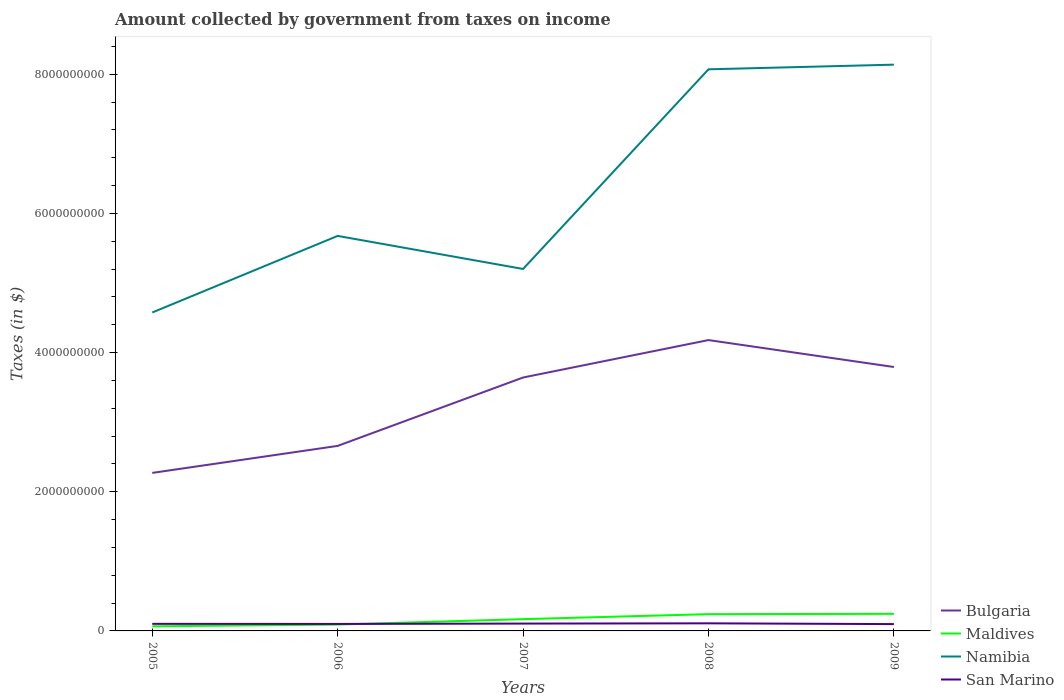Does the line corresponding to Namibia intersect with the line corresponding to San Marino?
Give a very brief answer. No. Is the number of lines equal to the number of legend labels?
Your answer should be compact. Yes. Across all years, what is the maximum amount collected by government from taxes on income in San Marino?
Your answer should be compact. 9.80e+07. In which year was the amount collected by government from taxes on income in Namibia maximum?
Offer a very short reply. 2005. What is the total amount collected by government from taxes on income in San Marino in the graph?
Provide a short and direct response. 7.55e+06. What is the difference between the highest and the second highest amount collected by government from taxes on income in Bulgaria?
Keep it short and to the point. 1.91e+09. Is the amount collected by government from taxes on income in Namibia strictly greater than the amount collected by government from taxes on income in San Marino over the years?
Your response must be concise. No. What is the difference between two consecutive major ticks on the Y-axis?
Ensure brevity in your answer.  2.00e+09. Are the values on the major ticks of Y-axis written in scientific E-notation?
Offer a very short reply. No. Does the graph contain any zero values?
Make the answer very short. No. Does the graph contain grids?
Provide a short and direct response. No. How many legend labels are there?
Give a very brief answer. 4. How are the legend labels stacked?
Your answer should be very brief. Vertical. What is the title of the graph?
Ensure brevity in your answer.  Amount collected by government from taxes on income. Does "Cyprus" appear as one of the legend labels in the graph?
Provide a succinct answer. No. What is the label or title of the Y-axis?
Ensure brevity in your answer.  Taxes (in $). What is the Taxes (in $) in Bulgaria in 2005?
Keep it short and to the point. 2.27e+09. What is the Taxes (in $) in Maldives in 2005?
Offer a terse response. 6.57e+07. What is the Taxes (in $) in Namibia in 2005?
Keep it short and to the point. 4.58e+09. What is the Taxes (in $) in San Marino in 2005?
Keep it short and to the point. 1.02e+08. What is the Taxes (in $) in Bulgaria in 2006?
Keep it short and to the point. 2.66e+09. What is the Taxes (in $) of Maldives in 2006?
Ensure brevity in your answer.  9.14e+07. What is the Taxes (in $) in Namibia in 2006?
Ensure brevity in your answer.  5.68e+09. What is the Taxes (in $) of San Marino in 2006?
Offer a terse response. 1.00e+08. What is the Taxes (in $) of Bulgaria in 2007?
Your answer should be very brief. 3.64e+09. What is the Taxes (in $) in Maldives in 2007?
Keep it short and to the point. 1.69e+08. What is the Taxes (in $) in Namibia in 2007?
Ensure brevity in your answer.  5.20e+09. What is the Taxes (in $) of San Marino in 2007?
Offer a very short reply. 1.06e+08. What is the Taxes (in $) in Bulgaria in 2008?
Offer a very short reply. 4.18e+09. What is the Taxes (in $) of Maldives in 2008?
Provide a short and direct response. 2.41e+08. What is the Taxes (in $) in Namibia in 2008?
Your answer should be compact. 8.07e+09. What is the Taxes (in $) in San Marino in 2008?
Make the answer very short. 1.09e+08. What is the Taxes (in $) in Bulgaria in 2009?
Keep it short and to the point. 3.79e+09. What is the Taxes (in $) of Maldives in 2009?
Your answer should be compact. 2.46e+08. What is the Taxes (in $) of Namibia in 2009?
Make the answer very short. 8.14e+09. What is the Taxes (in $) in San Marino in 2009?
Make the answer very short. 9.80e+07. Across all years, what is the maximum Taxes (in $) in Bulgaria?
Your answer should be very brief. 4.18e+09. Across all years, what is the maximum Taxes (in $) of Maldives?
Keep it short and to the point. 2.46e+08. Across all years, what is the maximum Taxes (in $) in Namibia?
Give a very brief answer. 8.14e+09. Across all years, what is the maximum Taxes (in $) of San Marino?
Offer a terse response. 1.09e+08. Across all years, what is the minimum Taxes (in $) of Bulgaria?
Provide a short and direct response. 2.27e+09. Across all years, what is the minimum Taxes (in $) in Maldives?
Keep it short and to the point. 6.57e+07. Across all years, what is the minimum Taxes (in $) of Namibia?
Make the answer very short. 4.58e+09. Across all years, what is the minimum Taxes (in $) in San Marino?
Your answer should be very brief. 9.80e+07. What is the total Taxes (in $) in Bulgaria in the graph?
Your response must be concise. 1.65e+1. What is the total Taxes (in $) in Maldives in the graph?
Keep it short and to the point. 8.13e+08. What is the total Taxes (in $) in Namibia in the graph?
Provide a short and direct response. 3.17e+1. What is the total Taxes (in $) in San Marino in the graph?
Provide a succinct answer. 5.15e+08. What is the difference between the Taxes (in $) of Bulgaria in 2005 and that in 2006?
Provide a succinct answer. -3.88e+08. What is the difference between the Taxes (in $) of Maldives in 2005 and that in 2006?
Make the answer very short. -2.57e+07. What is the difference between the Taxes (in $) of Namibia in 2005 and that in 2006?
Your response must be concise. -1.10e+09. What is the difference between the Taxes (in $) of San Marino in 2005 and that in 2006?
Offer a terse response. 1.49e+06. What is the difference between the Taxes (in $) of Bulgaria in 2005 and that in 2007?
Your answer should be compact. -1.37e+09. What is the difference between the Taxes (in $) in Maldives in 2005 and that in 2007?
Offer a terse response. -1.03e+08. What is the difference between the Taxes (in $) of Namibia in 2005 and that in 2007?
Your answer should be very brief. -6.25e+08. What is the difference between the Taxes (in $) of San Marino in 2005 and that in 2007?
Provide a short and direct response. -3.79e+06. What is the difference between the Taxes (in $) of Bulgaria in 2005 and that in 2008?
Provide a short and direct response. -1.91e+09. What is the difference between the Taxes (in $) of Maldives in 2005 and that in 2008?
Make the answer very short. -1.75e+08. What is the difference between the Taxes (in $) in Namibia in 2005 and that in 2008?
Your answer should be compact. -3.49e+09. What is the difference between the Taxes (in $) in San Marino in 2005 and that in 2008?
Offer a very short reply. -7.45e+06. What is the difference between the Taxes (in $) in Bulgaria in 2005 and that in 2009?
Offer a very short reply. -1.52e+09. What is the difference between the Taxes (in $) of Maldives in 2005 and that in 2009?
Your answer should be compact. -1.80e+08. What is the difference between the Taxes (in $) of Namibia in 2005 and that in 2009?
Make the answer very short. -3.56e+09. What is the difference between the Taxes (in $) of San Marino in 2005 and that in 2009?
Keep it short and to the point. 3.76e+06. What is the difference between the Taxes (in $) of Bulgaria in 2006 and that in 2007?
Your response must be concise. -9.83e+08. What is the difference between the Taxes (in $) of Maldives in 2006 and that in 2007?
Keep it short and to the point. -7.76e+07. What is the difference between the Taxes (in $) in Namibia in 2006 and that in 2007?
Your response must be concise. 4.75e+08. What is the difference between the Taxes (in $) of San Marino in 2006 and that in 2007?
Provide a succinct answer. -5.29e+06. What is the difference between the Taxes (in $) of Bulgaria in 2006 and that in 2008?
Ensure brevity in your answer.  -1.52e+09. What is the difference between the Taxes (in $) in Maldives in 2006 and that in 2008?
Keep it short and to the point. -1.49e+08. What is the difference between the Taxes (in $) of Namibia in 2006 and that in 2008?
Provide a short and direct response. -2.39e+09. What is the difference between the Taxes (in $) in San Marino in 2006 and that in 2008?
Make the answer very short. -8.94e+06. What is the difference between the Taxes (in $) in Bulgaria in 2006 and that in 2009?
Keep it short and to the point. -1.13e+09. What is the difference between the Taxes (in $) of Maldives in 2006 and that in 2009?
Your answer should be very brief. -1.54e+08. What is the difference between the Taxes (in $) of Namibia in 2006 and that in 2009?
Make the answer very short. -2.46e+09. What is the difference between the Taxes (in $) in San Marino in 2006 and that in 2009?
Offer a terse response. 2.27e+06. What is the difference between the Taxes (in $) in Bulgaria in 2007 and that in 2008?
Ensure brevity in your answer.  -5.38e+08. What is the difference between the Taxes (in $) of Maldives in 2007 and that in 2008?
Provide a succinct answer. -7.18e+07. What is the difference between the Taxes (in $) in Namibia in 2007 and that in 2008?
Your response must be concise. -2.87e+09. What is the difference between the Taxes (in $) of San Marino in 2007 and that in 2008?
Your answer should be very brief. -3.65e+06. What is the difference between the Taxes (in $) in Bulgaria in 2007 and that in 2009?
Make the answer very short. -1.51e+08. What is the difference between the Taxes (in $) of Maldives in 2007 and that in 2009?
Ensure brevity in your answer.  -7.67e+07. What is the difference between the Taxes (in $) in Namibia in 2007 and that in 2009?
Give a very brief answer. -2.94e+09. What is the difference between the Taxes (in $) of San Marino in 2007 and that in 2009?
Ensure brevity in your answer.  7.55e+06. What is the difference between the Taxes (in $) in Bulgaria in 2008 and that in 2009?
Your answer should be compact. 3.87e+08. What is the difference between the Taxes (in $) in Maldives in 2008 and that in 2009?
Your answer should be compact. -4.90e+06. What is the difference between the Taxes (in $) of Namibia in 2008 and that in 2009?
Offer a terse response. -6.70e+07. What is the difference between the Taxes (in $) of San Marino in 2008 and that in 2009?
Provide a succinct answer. 1.12e+07. What is the difference between the Taxes (in $) of Bulgaria in 2005 and the Taxes (in $) of Maldives in 2006?
Ensure brevity in your answer.  2.18e+09. What is the difference between the Taxes (in $) of Bulgaria in 2005 and the Taxes (in $) of Namibia in 2006?
Make the answer very short. -3.41e+09. What is the difference between the Taxes (in $) of Bulgaria in 2005 and the Taxes (in $) of San Marino in 2006?
Offer a terse response. 2.17e+09. What is the difference between the Taxes (in $) of Maldives in 2005 and the Taxes (in $) of Namibia in 2006?
Give a very brief answer. -5.61e+09. What is the difference between the Taxes (in $) of Maldives in 2005 and the Taxes (in $) of San Marino in 2006?
Give a very brief answer. -3.46e+07. What is the difference between the Taxes (in $) of Namibia in 2005 and the Taxes (in $) of San Marino in 2006?
Your answer should be compact. 4.48e+09. What is the difference between the Taxes (in $) in Bulgaria in 2005 and the Taxes (in $) in Maldives in 2007?
Your answer should be compact. 2.10e+09. What is the difference between the Taxes (in $) of Bulgaria in 2005 and the Taxes (in $) of Namibia in 2007?
Offer a terse response. -2.93e+09. What is the difference between the Taxes (in $) of Bulgaria in 2005 and the Taxes (in $) of San Marino in 2007?
Offer a very short reply. 2.17e+09. What is the difference between the Taxes (in $) of Maldives in 2005 and the Taxes (in $) of Namibia in 2007?
Make the answer very short. -5.14e+09. What is the difference between the Taxes (in $) in Maldives in 2005 and the Taxes (in $) in San Marino in 2007?
Give a very brief answer. -3.99e+07. What is the difference between the Taxes (in $) of Namibia in 2005 and the Taxes (in $) of San Marino in 2007?
Keep it short and to the point. 4.47e+09. What is the difference between the Taxes (in $) of Bulgaria in 2005 and the Taxes (in $) of Maldives in 2008?
Keep it short and to the point. 2.03e+09. What is the difference between the Taxes (in $) of Bulgaria in 2005 and the Taxes (in $) of Namibia in 2008?
Offer a very short reply. -5.80e+09. What is the difference between the Taxes (in $) in Bulgaria in 2005 and the Taxes (in $) in San Marino in 2008?
Offer a very short reply. 2.16e+09. What is the difference between the Taxes (in $) of Maldives in 2005 and the Taxes (in $) of Namibia in 2008?
Your response must be concise. -8.00e+09. What is the difference between the Taxes (in $) in Maldives in 2005 and the Taxes (in $) in San Marino in 2008?
Keep it short and to the point. -4.35e+07. What is the difference between the Taxes (in $) in Namibia in 2005 and the Taxes (in $) in San Marino in 2008?
Your answer should be compact. 4.47e+09. What is the difference between the Taxes (in $) in Bulgaria in 2005 and the Taxes (in $) in Maldives in 2009?
Provide a succinct answer. 2.02e+09. What is the difference between the Taxes (in $) in Bulgaria in 2005 and the Taxes (in $) in Namibia in 2009?
Keep it short and to the point. -5.87e+09. What is the difference between the Taxes (in $) of Bulgaria in 2005 and the Taxes (in $) of San Marino in 2009?
Offer a terse response. 2.17e+09. What is the difference between the Taxes (in $) of Maldives in 2005 and the Taxes (in $) of Namibia in 2009?
Give a very brief answer. -8.07e+09. What is the difference between the Taxes (in $) of Maldives in 2005 and the Taxes (in $) of San Marino in 2009?
Provide a succinct answer. -3.23e+07. What is the difference between the Taxes (in $) of Namibia in 2005 and the Taxes (in $) of San Marino in 2009?
Give a very brief answer. 4.48e+09. What is the difference between the Taxes (in $) of Bulgaria in 2006 and the Taxes (in $) of Maldives in 2007?
Offer a terse response. 2.49e+09. What is the difference between the Taxes (in $) of Bulgaria in 2006 and the Taxes (in $) of Namibia in 2007?
Provide a short and direct response. -2.54e+09. What is the difference between the Taxes (in $) in Bulgaria in 2006 and the Taxes (in $) in San Marino in 2007?
Offer a very short reply. 2.55e+09. What is the difference between the Taxes (in $) of Maldives in 2006 and the Taxes (in $) of Namibia in 2007?
Offer a very short reply. -5.11e+09. What is the difference between the Taxes (in $) in Maldives in 2006 and the Taxes (in $) in San Marino in 2007?
Keep it short and to the point. -1.42e+07. What is the difference between the Taxes (in $) of Namibia in 2006 and the Taxes (in $) of San Marino in 2007?
Give a very brief answer. 5.57e+09. What is the difference between the Taxes (in $) in Bulgaria in 2006 and the Taxes (in $) in Maldives in 2008?
Give a very brief answer. 2.42e+09. What is the difference between the Taxes (in $) of Bulgaria in 2006 and the Taxes (in $) of Namibia in 2008?
Keep it short and to the point. -5.41e+09. What is the difference between the Taxes (in $) in Bulgaria in 2006 and the Taxes (in $) in San Marino in 2008?
Give a very brief answer. 2.55e+09. What is the difference between the Taxes (in $) of Maldives in 2006 and the Taxes (in $) of Namibia in 2008?
Keep it short and to the point. -7.98e+09. What is the difference between the Taxes (in $) in Maldives in 2006 and the Taxes (in $) in San Marino in 2008?
Ensure brevity in your answer.  -1.78e+07. What is the difference between the Taxes (in $) of Namibia in 2006 and the Taxes (in $) of San Marino in 2008?
Offer a terse response. 5.57e+09. What is the difference between the Taxes (in $) of Bulgaria in 2006 and the Taxes (in $) of Maldives in 2009?
Make the answer very short. 2.41e+09. What is the difference between the Taxes (in $) of Bulgaria in 2006 and the Taxes (in $) of Namibia in 2009?
Keep it short and to the point. -5.48e+09. What is the difference between the Taxes (in $) in Bulgaria in 2006 and the Taxes (in $) in San Marino in 2009?
Give a very brief answer. 2.56e+09. What is the difference between the Taxes (in $) in Maldives in 2006 and the Taxes (in $) in Namibia in 2009?
Provide a succinct answer. -8.05e+09. What is the difference between the Taxes (in $) of Maldives in 2006 and the Taxes (in $) of San Marino in 2009?
Give a very brief answer. -6.60e+06. What is the difference between the Taxes (in $) of Namibia in 2006 and the Taxes (in $) of San Marino in 2009?
Your answer should be very brief. 5.58e+09. What is the difference between the Taxes (in $) in Bulgaria in 2007 and the Taxes (in $) in Maldives in 2008?
Keep it short and to the point. 3.40e+09. What is the difference between the Taxes (in $) in Bulgaria in 2007 and the Taxes (in $) in Namibia in 2008?
Give a very brief answer. -4.43e+09. What is the difference between the Taxes (in $) of Bulgaria in 2007 and the Taxes (in $) of San Marino in 2008?
Give a very brief answer. 3.53e+09. What is the difference between the Taxes (in $) of Maldives in 2007 and the Taxes (in $) of Namibia in 2008?
Give a very brief answer. -7.90e+09. What is the difference between the Taxes (in $) of Maldives in 2007 and the Taxes (in $) of San Marino in 2008?
Keep it short and to the point. 5.98e+07. What is the difference between the Taxes (in $) in Namibia in 2007 and the Taxes (in $) in San Marino in 2008?
Offer a terse response. 5.09e+09. What is the difference between the Taxes (in $) of Bulgaria in 2007 and the Taxes (in $) of Maldives in 2009?
Offer a terse response. 3.40e+09. What is the difference between the Taxes (in $) in Bulgaria in 2007 and the Taxes (in $) in Namibia in 2009?
Provide a short and direct response. -4.50e+09. What is the difference between the Taxes (in $) in Bulgaria in 2007 and the Taxes (in $) in San Marino in 2009?
Keep it short and to the point. 3.54e+09. What is the difference between the Taxes (in $) of Maldives in 2007 and the Taxes (in $) of Namibia in 2009?
Give a very brief answer. -7.97e+09. What is the difference between the Taxes (in $) of Maldives in 2007 and the Taxes (in $) of San Marino in 2009?
Your answer should be very brief. 7.10e+07. What is the difference between the Taxes (in $) of Namibia in 2007 and the Taxes (in $) of San Marino in 2009?
Your answer should be compact. 5.10e+09. What is the difference between the Taxes (in $) of Bulgaria in 2008 and the Taxes (in $) of Maldives in 2009?
Ensure brevity in your answer.  3.93e+09. What is the difference between the Taxes (in $) in Bulgaria in 2008 and the Taxes (in $) in Namibia in 2009?
Give a very brief answer. -3.96e+09. What is the difference between the Taxes (in $) in Bulgaria in 2008 and the Taxes (in $) in San Marino in 2009?
Your answer should be compact. 4.08e+09. What is the difference between the Taxes (in $) of Maldives in 2008 and the Taxes (in $) of Namibia in 2009?
Keep it short and to the point. -7.90e+09. What is the difference between the Taxes (in $) in Maldives in 2008 and the Taxes (in $) in San Marino in 2009?
Offer a very short reply. 1.43e+08. What is the difference between the Taxes (in $) in Namibia in 2008 and the Taxes (in $) in San Marino in 2009?
Make the answer very short. 7.97e+09. What is the average Taxes (in $) in Bulgaria per year?
Offer a very short reply. 3.31e+09. What is the average Taxes (in $) in Maldives per year?
Keep it short and to the point. 1.63e+08. What is the average Taxes (in $) in Namibia per year?
Provide a short and direct response. 6.33e+09. What is the average Taxes (in $) in San Marino per year?
Offer a terse response. 1.03e+08. In the year 2005, what is the difference between the Taxes (in $) of Bulgaria and Taxes (in $) of Maldives?
Your answer should be very brief. 2.20e+09. In the year 2005, what is the difference between the Taxes (in $) of Bulgaria and Taxes (in $) of Namibia?
Your answer should be very brief. -2.30e+09. In the year 2005, what is the difference between the Taxes (in $) in Bulgaria and Taxes (in $) in San Marino?
Provide a succinct answer. 2.17e+09. In the year 2005, what is the difference between the Taxes (in $) in Maldives and Taxes (in $) in Namibia?
Make the answer very short. -4.51e+09. In the year 2005, what is the difference between the Taxes (in $) of Maldives and Taxes (in $) of San Marino?
Make the answer very short. -3.61e+07. In the year 2005, what is the difference between the Taxes (in $) of Namibia and Taxes (in $) of San Marino?
Provide a succinct answer. 4.47e+09. In the year 2006, what is the difference between the Taxes (in $) in Bulgaria and Taxes (in $) in Maldives?
Your answer should be compact. 2.57e+09. In the year 2006, what is the difference between the Taxes (in $) in Bulgaria and Taxes (in $) in Namibia?
Your answer should be compact. -3.02e+09. In the year 2006, what is the difference between the Taxes (in $) of Bulgaria and Taxes (in $) of San Marino?
Give a very brief answer. 2.56e+09. In the year 2006, what is the difference between the Taxes (in $) of Maldives and Taxes (in $) of Namibia?
Give a very brief answer. -5.58e+09. In the year 2006, what is the difference between the Taxes (in $) of Maldives and Taxes (in $) of San Marino?
Your answer should be compact. -8.86e+06. In the year 2006, what is the difference between the Taxes (in $) in Namibia and Taxes (in $) in San Marino?
Your answer should be very brief. 5.58e+09. In the year 2007, what is the difference between the Taxes (in $) of Bulgaria and Taxes (in $) of Maldives?
Your answer should be very brief. 3.47e+09. In the year 2007, what is the difference between the Taxes (in $) in Bulgaria and Taxes (in $) in Namibia?
Give a very brief answer. -1.56e+09. In the year 2007, what is the difference between the Taxes (in $) of Bulgaria and Taxes (in $) of San Marino?
Offer a terse response. 3.54e+09. In the year 2007, what is the difference between the Taxes (in $) in Maldives and Taxes (in $) in Namibia?
Offer a terse response. -5.03e+09. In the year 2007, what is the difference between the Taxes (in $) in Maldives and Taxes (in $) in San Marino?
Your response must be concise. 6.34e+07. In the year 2007, what is the difference between the Taxes (in $) in Namibia and Taxes (in $) in San Marino?
Keep it short and to the point. 5.10e+09. In the year 2008, what is the difference between the Taxes (in $) of Bulgaria and Taxes (in $) of Maldives?
Make the answer very short. 3.94e+09. In the year 2008, what is the difference between the Taxes (in $) in Bulgaria and Taxes (in $) in Namibia?
Ensure brevity in your answer.  -3.89e+09. In the year 2008, what is the difference between the Taxes (in $) of Bulgaria and Taxes (in $) of San Marino?
Your answer should be compact. 4.07e+09. In the year 2008, what is the difference between the Taxes (in $) in Maldives and Taxes (in $) in Namibia?
Provide a short and direct response. -7.83e+09. In the year 2008, what is the difference between the Taxes (in $) in Maldives and Taxes (in $) in San Marino?
Offer a terse response. 1.32e+08. In the year 2008, what is the difference between the Taxes (in $) in Namibia and Taxes (in $) in San Marino?
Your answer should be compact. 7.96e+09. In the year 2009, what is the difference between the Taxes (in $) in Bulgaria and Taxes (in $) in Maldives?
Offer a very short reply. 3.55e+09. In the year 2009, what is the difference between the Taxes (in $) of Bulgaria and Taxes (in $) of Namibia?
Provide a short and direct response. -4.34e+09. In the year 2009, what is the difference between the Taxes (in $) in Bulgaria and Taxes (in $) in San Marino?
Keep it short and to the point. 3.69e+09. In the year 2009, what is the difference between the Taxes (in $) in Maldives and Taxes (in $) in Namibia?
Your response must be concise. -7.89e+09. In the year 2009, what is the difference between the Taxes (in $) in Maldives and Taxes (in $) in San Marino?
Make the answer very short. 1.48e+08. In the year 2009, what is the difference between the Taxes (in $) in Namibia and Taxes (in $) in San Marino?
Provide a short and direct response. 8.04e+09. What is the ratio of the Taxes (in $) in Bulgaria in 2005 to that in 2006?
Provide a short and direct response. 0.85. What is the ratio of the Taxes (in $) of Maldives in 2005 to that in 2006?
Make the answer very short. 0.72. What is the ratio of the Taxes (in $) in Namibia in 2005 to that in 2006?
Offer a very short reply. 0.81. What is the ratio of the Taxes (in $) in San Marino in 2005 to that in 2006?
Your response must be concise. 1.01. What is the ratio of the Taxes (in $) of Bulgaria in 2005 to that in 2007?
Your answer should be very brief. 0.62. What is the ratio of the Taxes (in $) in Maldives in 2005 to that in 2007?
Your answer should be compact. 0.39. What is the ratio of the Taxes (in $) in Namibia in 2005 to that in 2007?
Provide a succinct answer. 0.88. What is the ratio of the Taxes (in $) of Bulgaria in 2005 to that in 2008?
Give a very brief answer. 0.54. What is the ratio of the Taxes (in $) of Maldives in 2005 to that in 2008?
Make the answer very short. 0.27. What is the ratio of the Taxes (in $) in Namibia in 2005 to that in 2008?
Keep it short and to the point. 0.57. What is the ratio of the Taxes (in $) of San Marino in 2005 to that in 2008?
Keep it short and to the point. 0.93. What is the ratio of the Taxes (in $) of Bulgaria in 2005 to that in 2009?
Keep it short and to the point. 0.6. What is the ratio of the Taxes (in $) in Maldives in 2005 to that in 2009?
Provide a succinct answer. 0.27. What is the ratio of the Taxes (in $) in Namibia in 2005 to that in 2009?
Your answer should be very brief. 0.56. What is the ratio of the Taxes (in $) in San Marino in 2005 to that in 2009?
Your response must be concise. 1.04. What is the ratio of the Taxes (in $) in Bulgaria in 2006 to that in 2007?
Your response must be concise. 0.73. What is the ratio of the Taxes (in $) in Maldives in 2006 to that in 2007?
Give a very brief answer. 0.54. What is the ratio of the Taxes (in $) of Namibia in 2006 to that in 2007?
Provide a short and direct response. 1.09. What is the ratio of the Taxes (in $) of San Marino in 2006 to that in 2007?
Provide a succinct answer. 0.95. What is the ratio of the Taxes (in $) of Bulgaria in 2006 to that in 2008?
Provide a succinct answer. 0.64. What is the ratio of the Taxes (in $) in Maldives in 2006 to that in 2008?
Provide a short and direct response. 0.38. What is the ratio of the Taxes (in $) in Namibia in 2006 to that in 2008?
Ensure brevity in your answer.  0.7. What is the ratio of the Taxes (in $) of San Marino in 2006 to that in 2008?
Keep it short and to the point. 0.92. What is the ratio of the Taxes (in $) in Bulgaria in 2006 to that in 2009?
Your response must be concise. 0.7. What is the ratio of the Taxes (in $) of Maldives in 2006 to that in 2009?
Offer a terse response. 0.37. What is the ratio of the Taxes (in $) in Namibia in 2006 to that in 2009?
Ensure brevity in your answer.  0.7. What is the ratio of the Taxes (in $) in San Marino in 2006 to that in 2009?
Offer a terse response. 1.02. What is the ratio of the Taxes (in $) of Bulgaria in 2007 to that in 2008?
Offer a very short reply. 0.87. What is the ratio of the Taxes (in $) of Maldives in 2007 to that in 2008?
Your answer should be compact. 0.7. What is the ratio of the Taxes (in $) of Namibia in 2007 to that in 2008?
Make the answer very short. 0.64. What is the ratio of the Taxes (in $) of San Marino in 2007 to that in 2008?
Your answer should be compact. 0.97. What is the ratio of the Taxes (in $) in Bulgaria in 2007 to that in 2009?
Offer a very short reply. 0.96. What is the ratio of the Taxes (in $) in Maldives in 2007 to that in 2009?
Your answer should be compact. 0.69. What is the ratio of the Taxes (in $) in Namibia in 2007 to that in 2009?
Provide a short and direct response. 0.64. What is the ratio of the Taxes (in $) of San Marino in 2007 to that in 2009?
Your answer should be very brief. 1.08. What is the ratio of the Taxes (in $) in Bulgaria in 2008 to that in 2009?
Give a very brief answer. 1.1. What is the ratio of the Taxes (in $) in Maldives in 2008 to that in 2009?
Offer a terse response. 0.98. What is the ratio of the Taxes (in $) of Namibia in 2008 to that in 2009?
Make the answer very short. 0.99. What is the ratio of the Taxes (in $) in San Marino in 2008 to that in 2009?
Offer a very short reply. 1.11. What is the difference between the highest and the second highest Taxes (in $) of Bulgaria?
Your response must be concise. 3.87e+08. What is the difference between the highest and the second highest Taxes (in $) of Maldives?
Offer a very short reply. 4.90e+06. What is the difference between the highest and the second highest Taxes (in $) in Namibia?
Provide a short and direct response. 6.70e+07. What is the difference between the highest and the second highest Taxes (in $) in San Marino?
Give a very brief answer. 3.65e+06. What is the difference between the highest and the lowest Taxes (in $) of Bulgaria?
Your response must be concise. 1.91e+09. What is the difference between the highest and the lowest Taxes (in $) in Maldives?
Provide a short and direct response. 1.80e+08. What is the difference between the highest and the lowest Taxes (in $) of Namibia?
Offer a terse response. 3.56e+09. What is the difference between the highest and the lowest Taxes (in $) in San Marino?
Provide a short and direct response. 1.12e+07. 